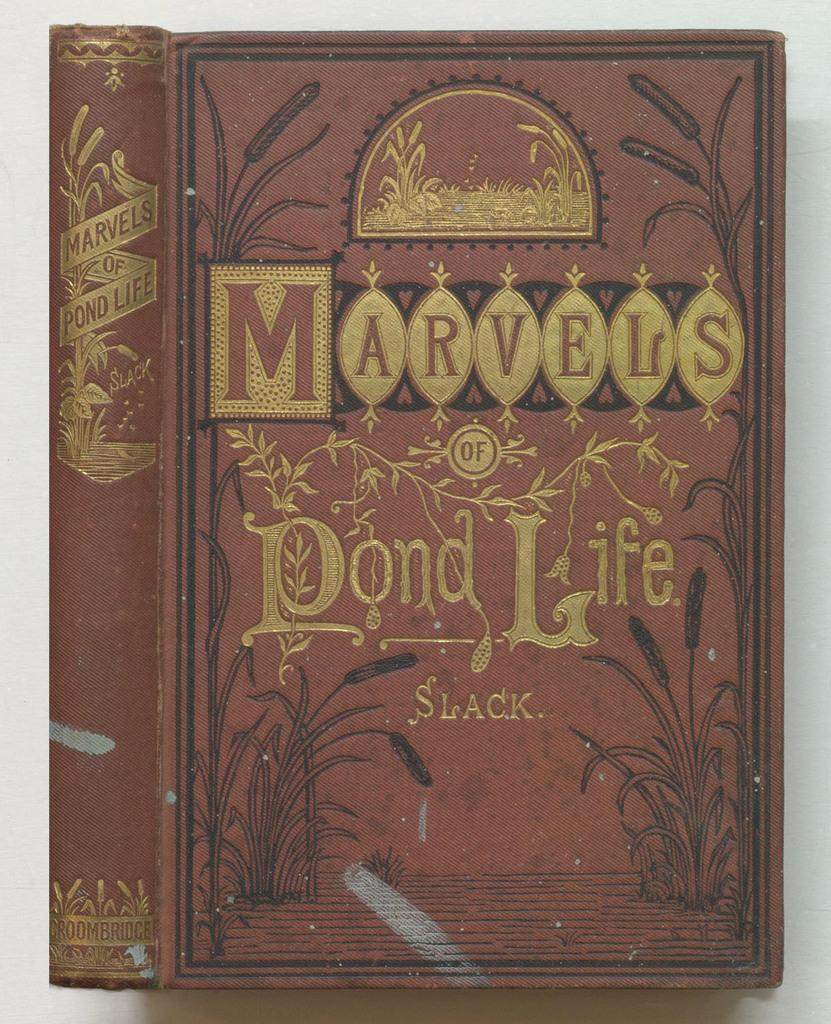<image>
Summarize the visual content of the image. A book is titled "Marvels of Pond Life," written by Slack. 